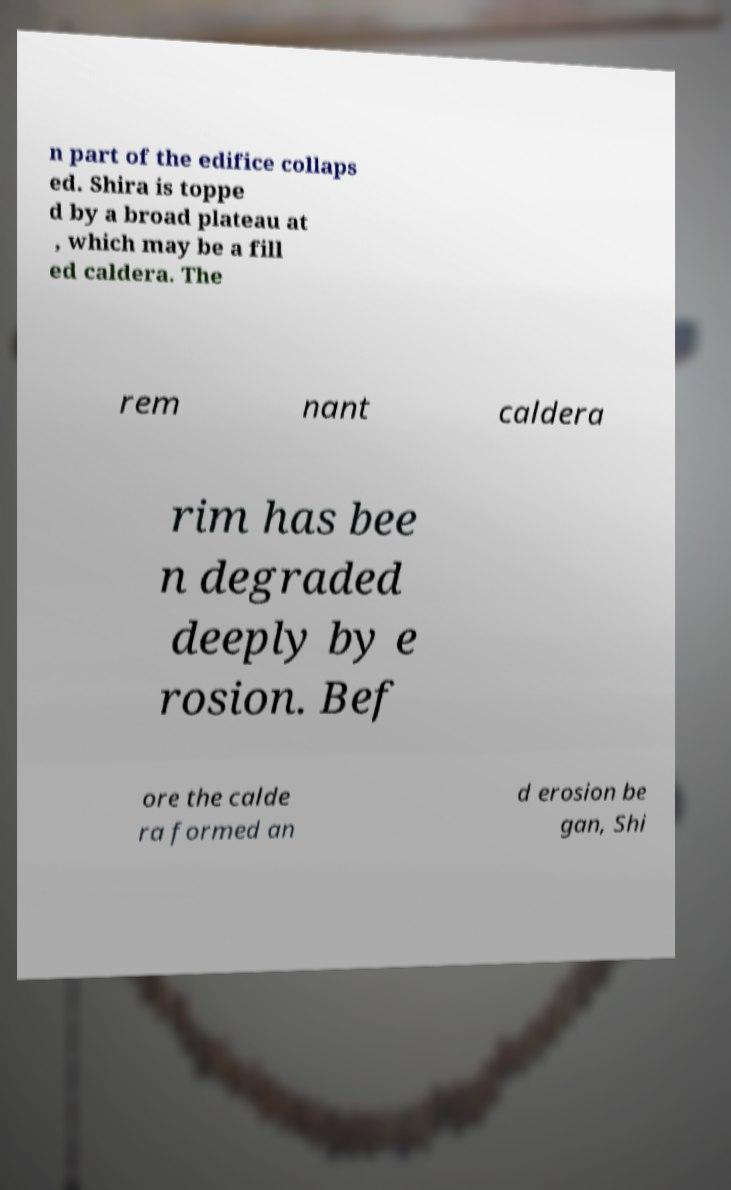There's text embedded in this image that I need extracted. Can you transcribe it verbatim? n part of the edifice collaps ed. Shira is toppe d by a broad plateau at , which may be a fill ed caldera. The rem nant caldera rim has bee n degraded deeply by e rosion. Bef ore the calde ra formed an d erosion be gan, Shi 